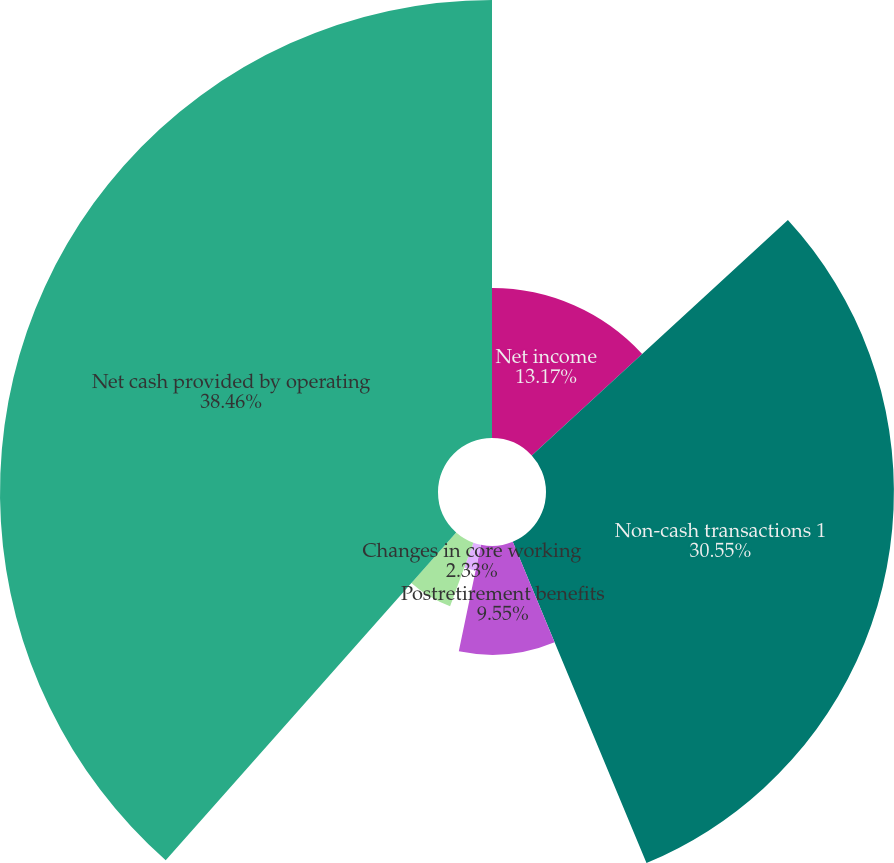<chart> <loc_0><loc_0><loc_500><loc_500><pie_chart><fcel>Net income<fcel>Non-cash transactions 1<fcel>Postretirement benefits<fcel>Changes in core working<fcel>Changes in other assets and<fcel>Net cash provided by operating<nl><fcel>13.17%<fcel>30.55%<fcel>9.55%<fcel>2.33%<fcel>5.94%<fcel>38.46%<nl></chart> 